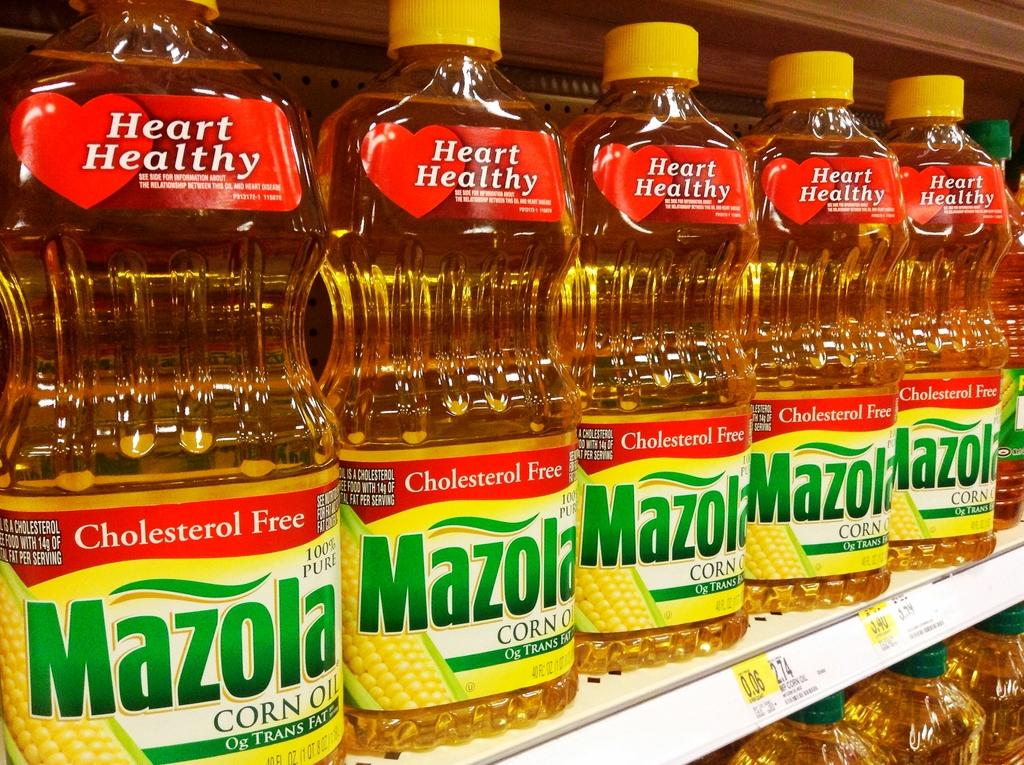<image>
Render a clear and concise summary of the photo. The shelf is filled with bottles of cholesterol free Mazola Corn Oil. 